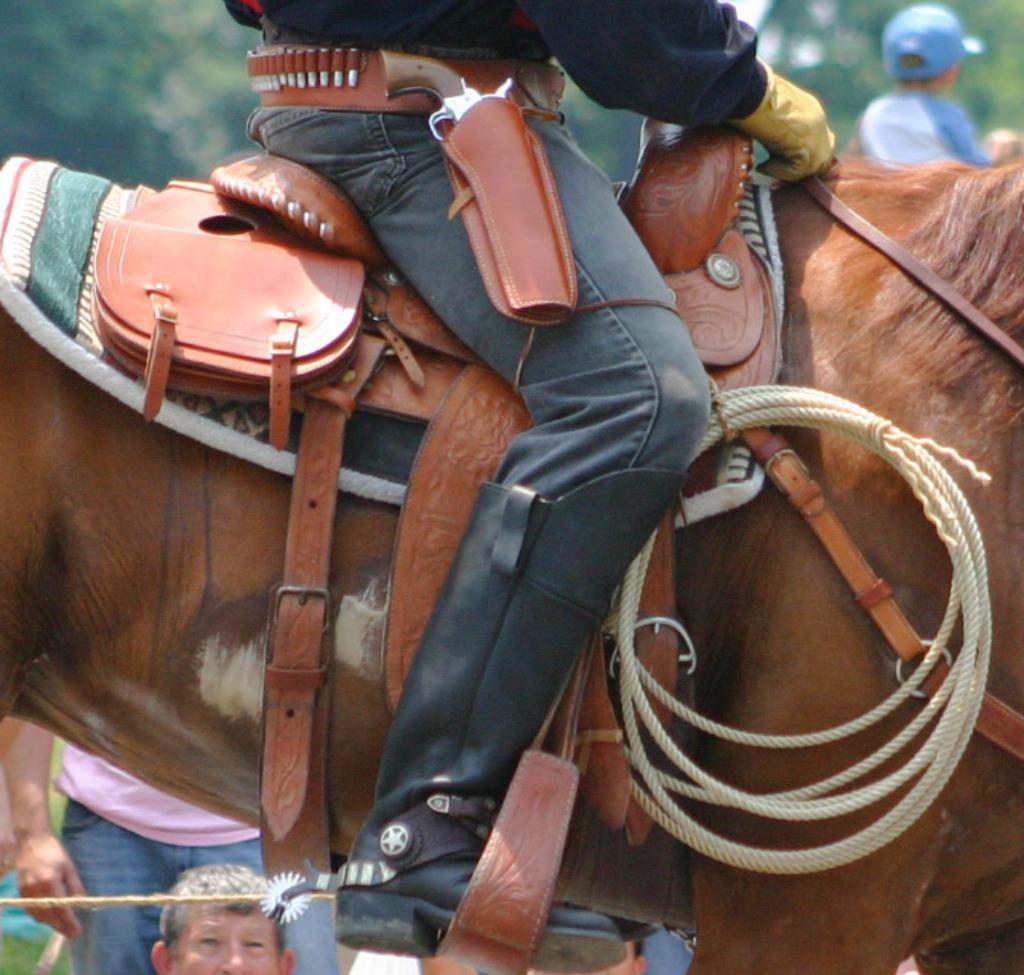How would you summarize this image in a sentence or two? In this image there is a person sitting on the horse, on the horse there are ropes and some other objects and there are a few people standing, on the top right side of the image there is a person. In the background there are trees. 